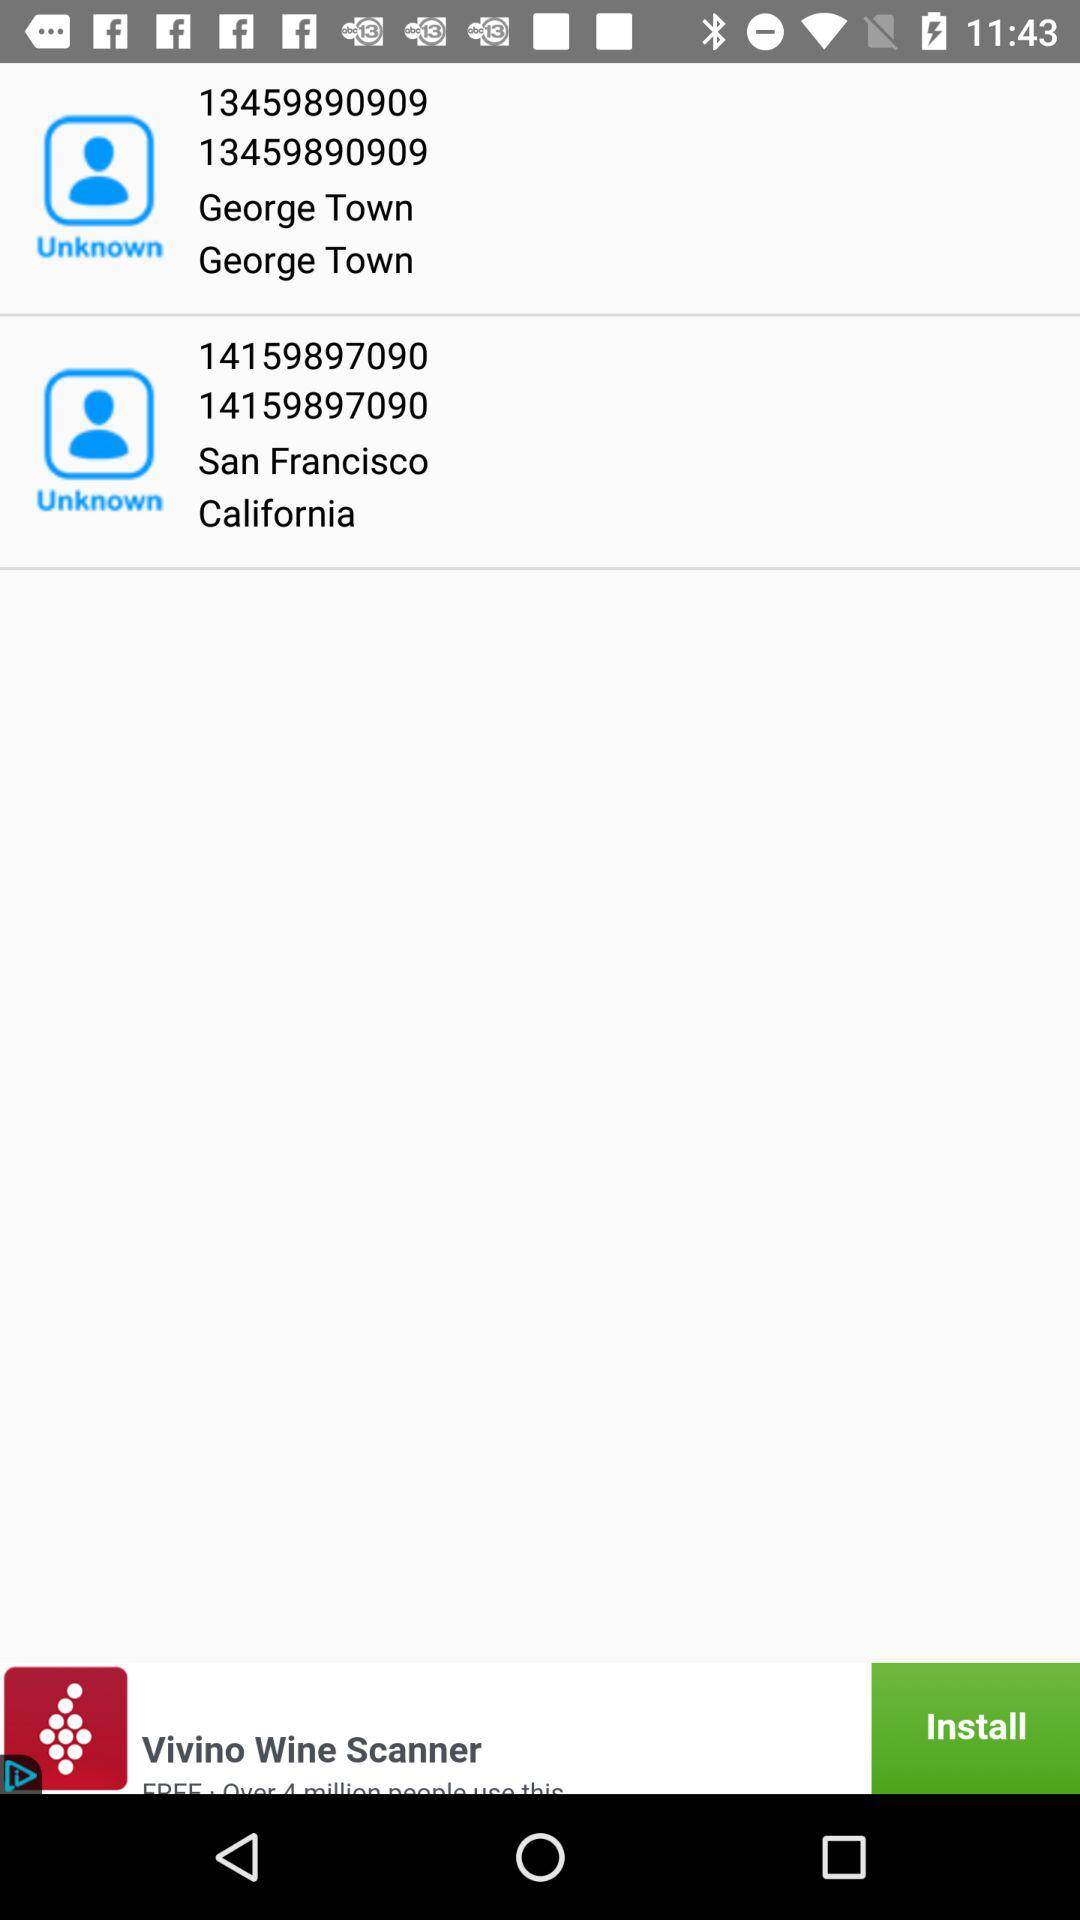What is the number for George Town? The number is 13459890909. 